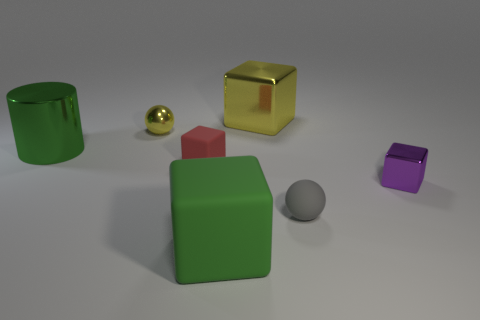What materials do the objects in the image seem to be made of? The objects display characteristics of various materials. The cylinder and the small ball appear to be made of a reflective metal, while the cubes and the sphere look like they could be made of plastic or a matte-painted material due to their diffuse surfaces. 